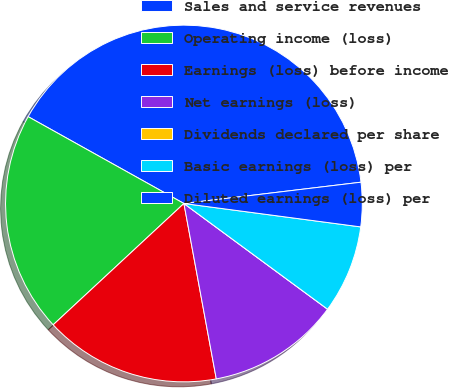<chart> <loc_0><loc_0><loc_500><loc_500><pie_chart><fcel>Sales and service revenues<fcel>Operating income (loss)<fcel>Earnings (loss) before income<fcel>Net earnings (loss)<fcel>Dividends declared per share<fcel>Basic earnings (loss) per<fcel>Diluted earnings (loss) per<nl><fcel>40.0%<fcel>20.0%<fcel>16.0%<fcel>12.0%<fcel>0.0%<fcel>8.0%<fcel>4.0%<nl></chart> 